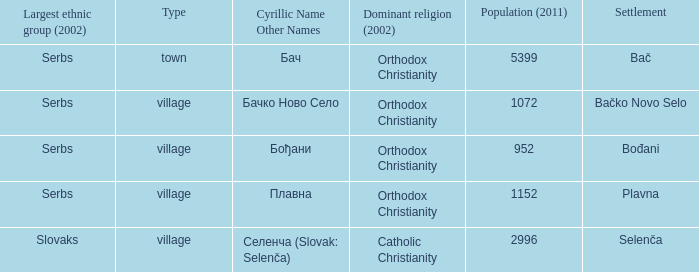What is the second way of writting плавна. Plavna. 